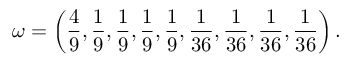Convert formula to latex. <formula><loc_0><loc_0><loc_500><loc_500>\omega = \left ( \frac { 4 } { 9 } , \frac { 1 } { 9 } , \frac { 1 } { 9 } , \frac { 1 } { 9 } , \frac { 1 } { 9 } , \frac { 1 } { 3 6 } , \frac { 1 } { 3 6 } , \frac { 1 } { 3 6 } , \frac { 1 } { 3 6 } \right ) .</formula> 